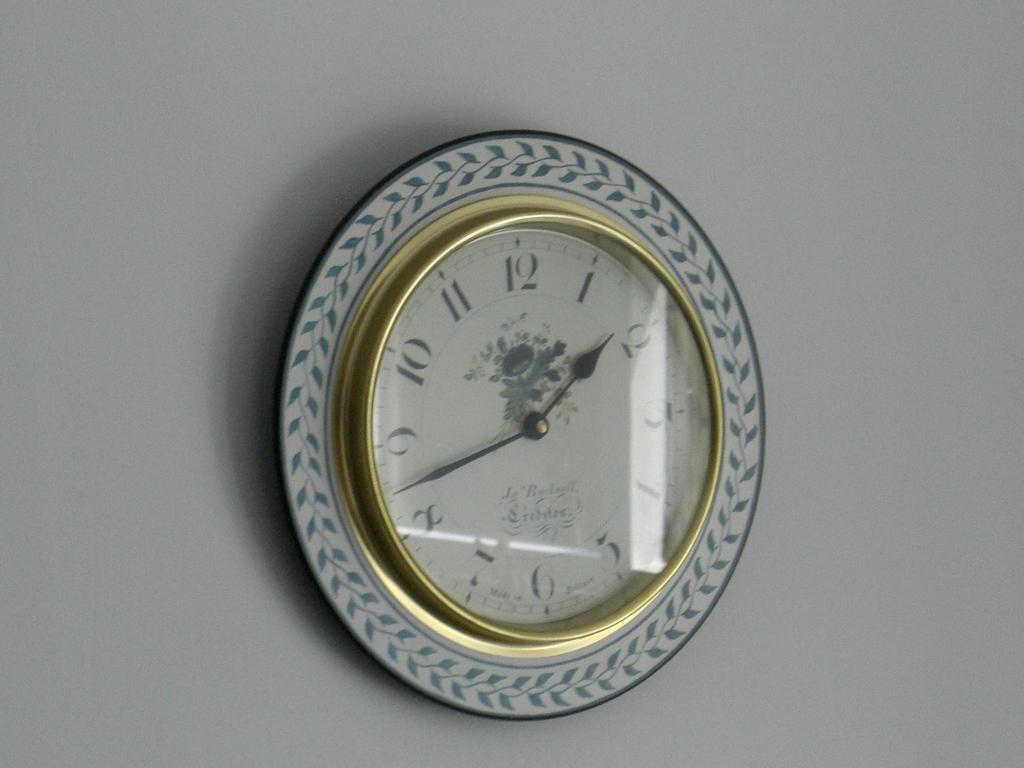What is the main subject in the center of the image? There is a wall in the center of the image. What is attached to the wall? There is a wall clock on the wall. What type of cakes are being served in the town depicted in the image? There is no town or cakes present in the image; it only features a wall with a wall clock. 